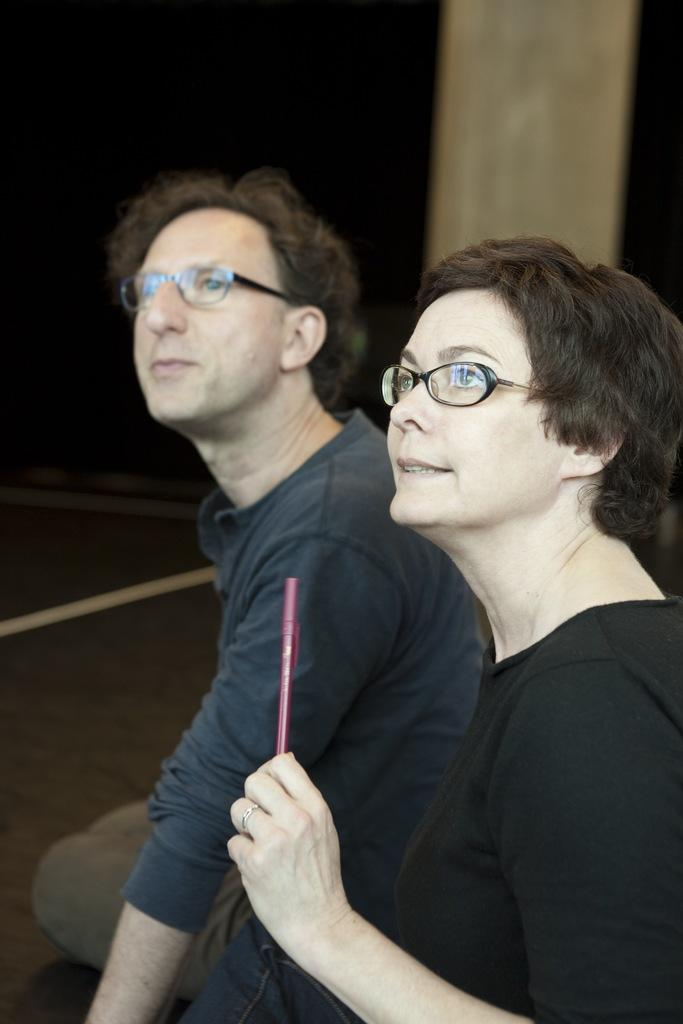Who is present in the image? There is a man and a woman in the image. What are the man and woman doing in the image? The man and woman are sitting on the floor. What is the woman holding in the image? The woman is holding a pen. What can be seen in the background of the image? There is a pillar in the background of the image. How would you describe the lighting in the image? The background of the image is dark. What type of hose is being used for the war in the image? There is no war or hose present in the image. The image features a man and a woman sitting on the floor, with the woman holding a pen. 